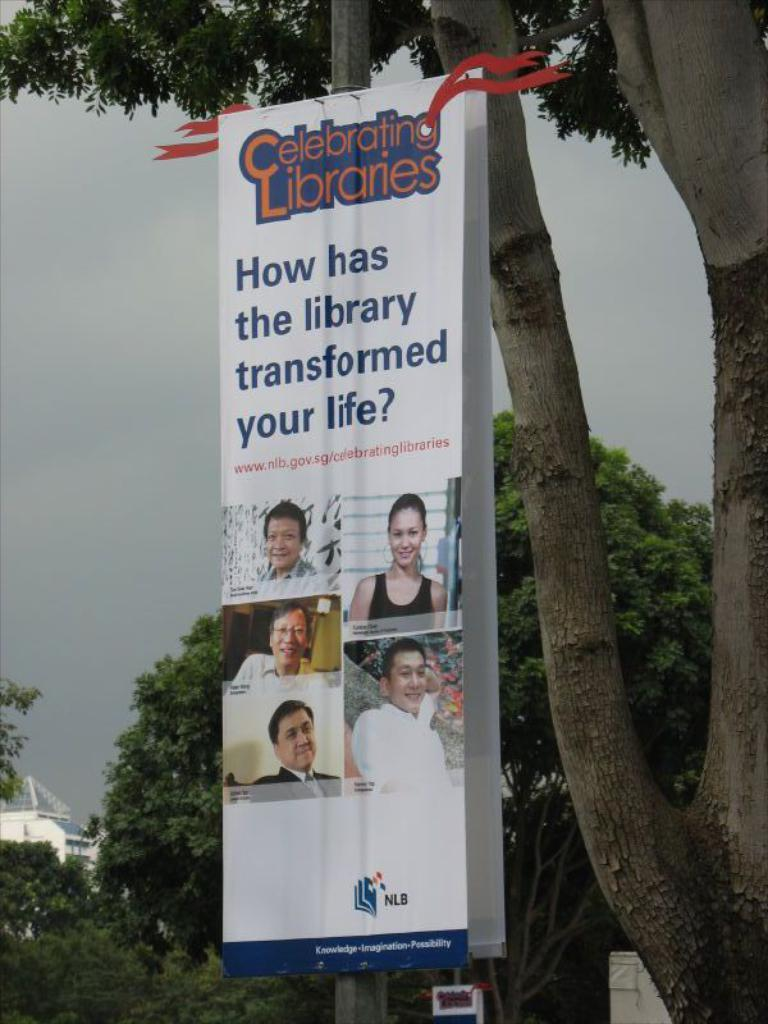What is hanging or displayed in the image? There is a banner in the image. What type of natural elements can be seen in the image? There are trees in the image. What type of man-made structure is visible in the image? There is a building in the image. What can be seen in the distance or background of the image? The sky is visible in the background of the image. What type of texture can be seen on the coal in the image? There is no coal present in the image. What is the stick used for in the image? There is no stick present in the image. 